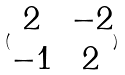<formula> <loc_0><loc_0><loc_500><loc_500>( \begin{matrix} 2 & - 2 \\ - 1 & 2 \end{matrix} )</formula> 